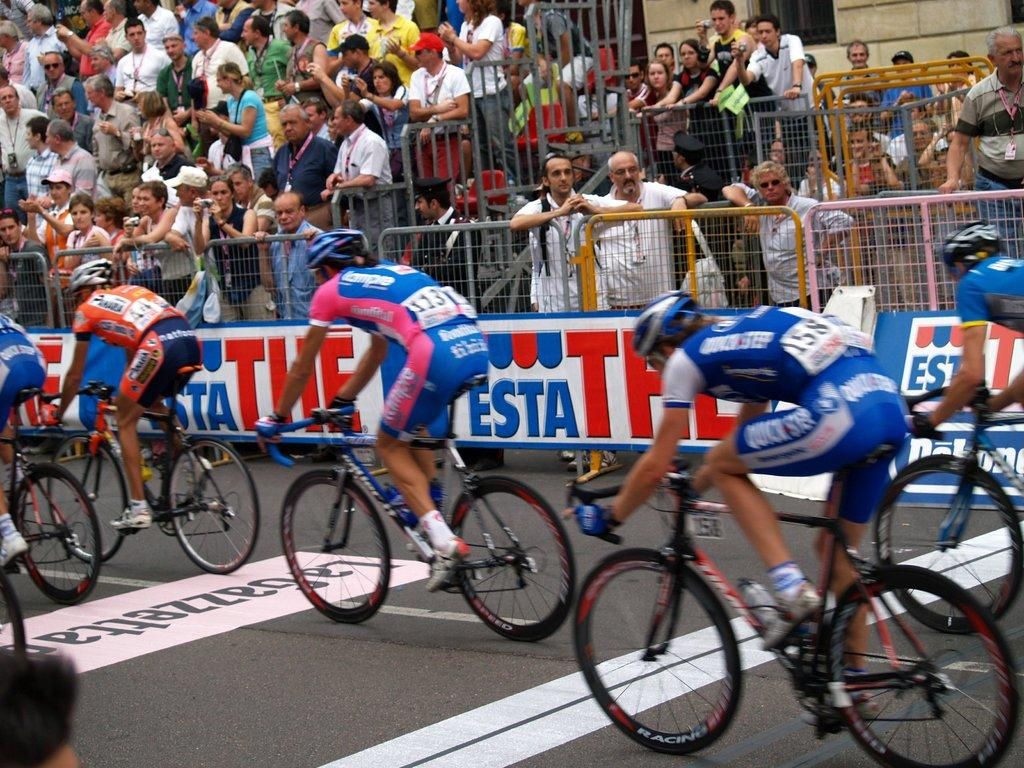Provide a one-sentence caption for the provided image. Number 44 is the only rider not wearing blue in the group. 